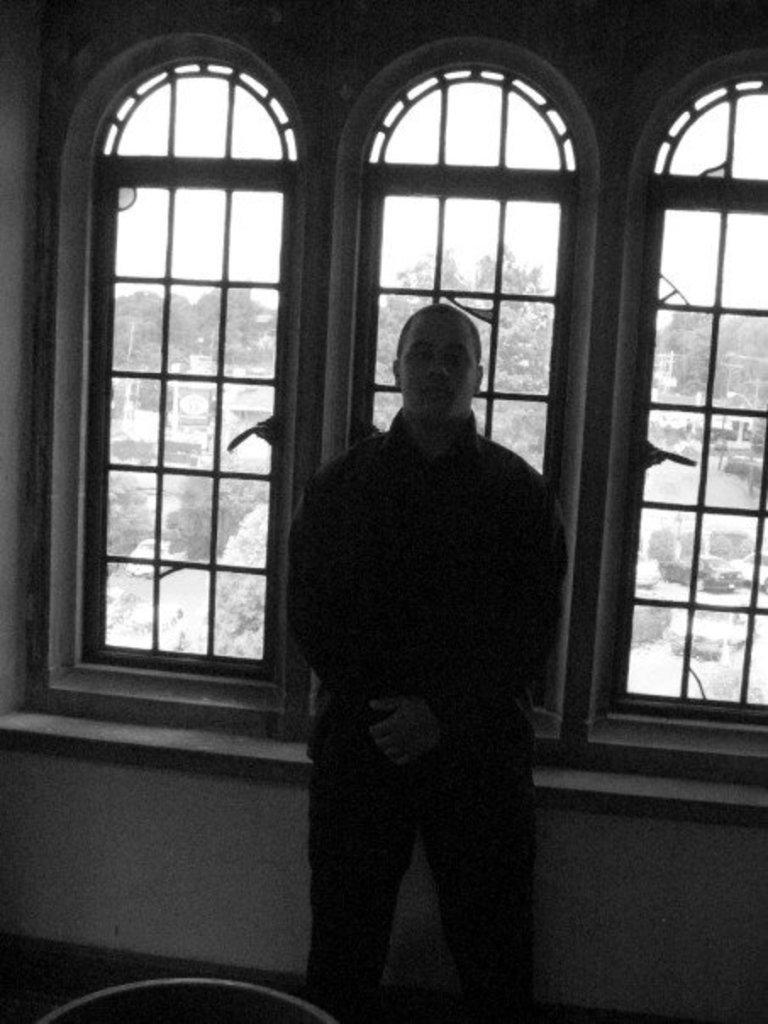What is the main subject of the image? There is a man standing in the image. What can be seen in the background of the image? There is a window and a wall in the background of the image. What is located at the bottom of the image? There is a floor at the bottom of the image. What is visible through the window in the image? Trees and buildings are visible through the window. Where is the stove located in the image? There is no stove present in the image. What is the thumb doing in the image? There is no thumb visible in the image. 